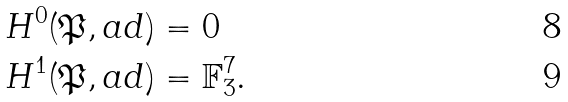<formula> <loc_0><loc_0><loc_500><loc_500>H ^ { 0 } ( \mathfrak { P } , a d ) & = 0 \\ H ^ { 1 } ( \mathfrak { P } , a d ) & = \mathbb { F } _ { 3 } ^ { 7 } .</formula> 